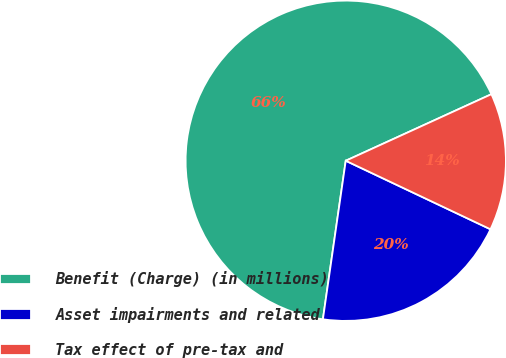Convert chart to OTSL. <chart><loc_0><loc_0><loc_500><loc_500><pie_chart><fcel>Benefit (Charge) (in millions)<fcel>Asset impairments and related<fcel>Tax effect of pre-tax and<nl><fcel>65.9%<fcel>20.24%<fcel>13.86%<nl></chart> 